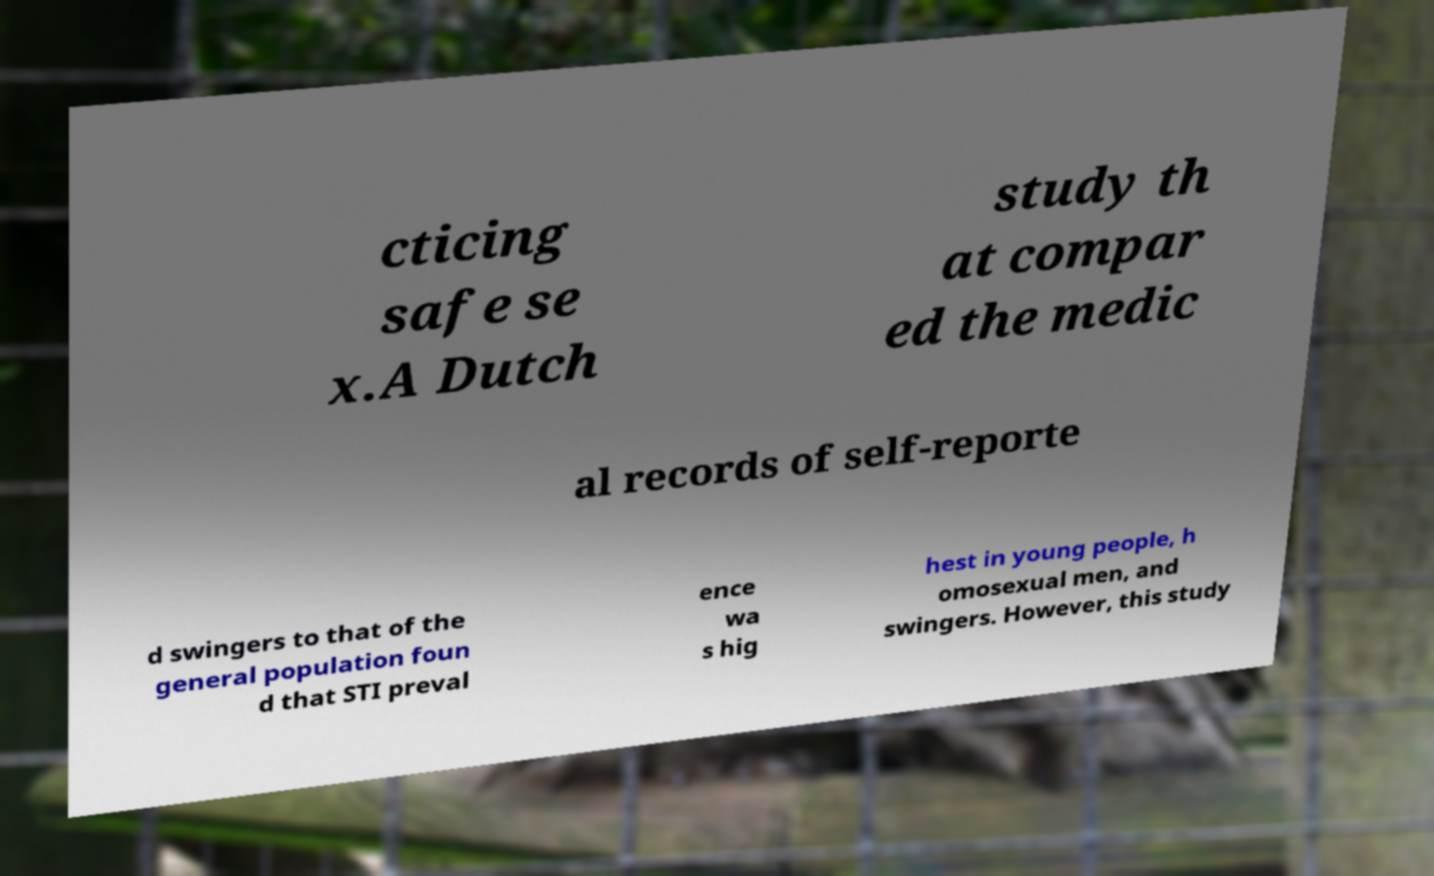Could you extract and type out the text from this image? cticing safe se x.A Dutch study th at compar ed the medic al records of self-reporte d swingers to that of the general population foun d that STI preval ence wa s hig hest in young people, h omosexual men, and swingers. However, this study 